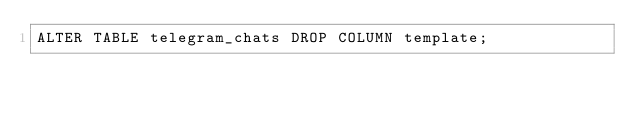<code> <loc_0><loc_0><loc_500><loc_500><_SQL_>ALTER TABLE telegram_chats DROP COLUMN template;
</code> 